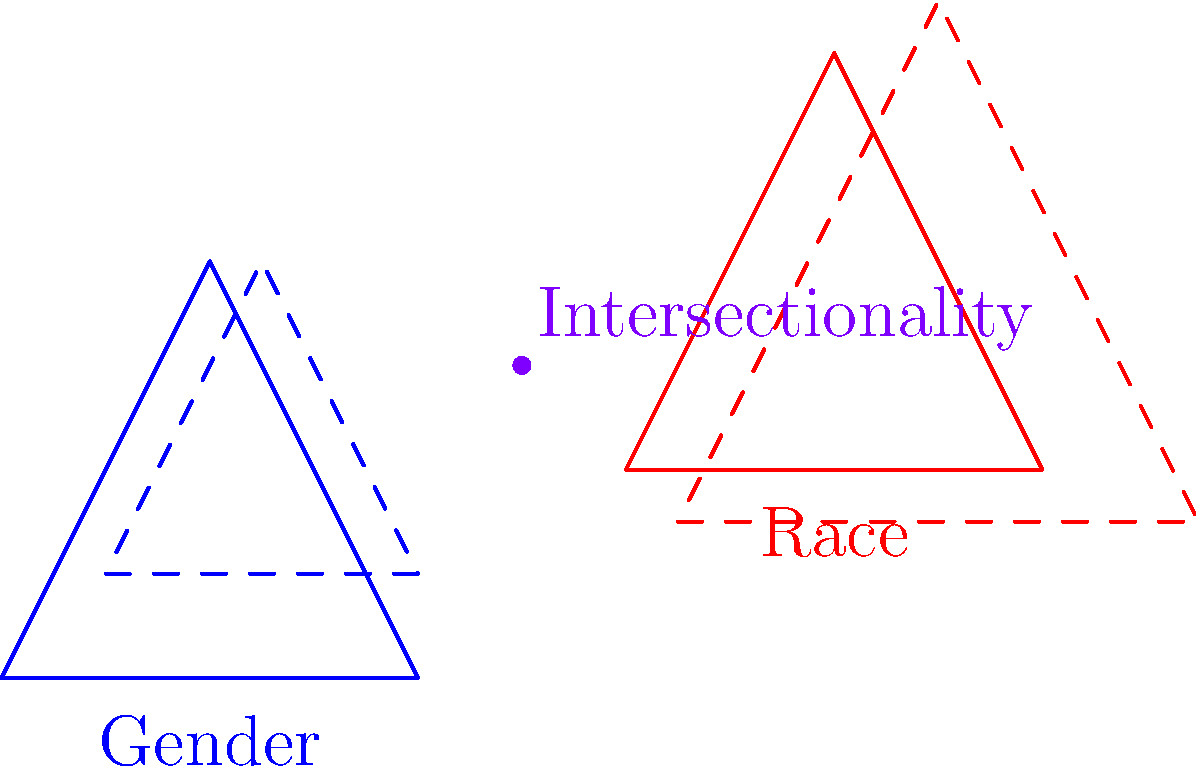In the diagram, two triangles represent different aspects of identity: gender (blue) and race (red). The intersection point symbolizes intersectionality in feminist theory. If we scale the blue triangle by a factor of 0.75 and translate it by (0.5, 0.5), and scale the red triangle by a factor of 1.25 and translate it by (-0.5, -0.5), how does this transformation affect the intersectionality point? Explain the significance of this transformation in terms of Regina Kunzel's work on intersectional analysis in gender and sexuality studies. To understand the transformation's effect on the intersectionality point, let's follow these steps:

1. Original intersectionality point: (2.5, 1.5)

2. Blue triangle (gender) transformation:
   a. Scale by 0.75: $(2.5 * 0.75, 1.5 * 0.75) = (1.875, 1.125)$
   b. Translate by (0.5, 0.5): $(1.875 + 0.5, 1.125 + 0.5) = (2.375, 1.625)$

3. Red triangle (race) transformation:
   a. Scale by 1.25: $(2.5 * 1.25, 1.5 * 1.25) = (3.125, 1.875)$
   b. Translate by (-0.5, -0.5): $(3.125 - 0.5, 1.875 - 0.5) = (2.625, 1.375)$

4. The new intersectionality point would be between (2.375, 1.625) and (2.625, 1.375)

This transformation reflects Kunzel's work on intersectional analysis by demonstrating:

a. The dynamic nature of intersectionality: The shifting point shows that intersections of identity are not fixed but can change based on context and perspective.

b. Relative importance of factors: The scaling represents how certain aspects of identity may become more or less prominent in different situations.

c. Contextual shifts: The translation symbolizes how social, cultural, or historical contexts can shift the relationship between different identity factors.

d. Complexity of identity: The transformation illustrates that understanding intersectionality requires considering multiple, simultaneous changes in how identity categories interact.

e. Non-additive nature: The new intersection point is not a simple combination of the individual transformations, reflecting Kunzel's emphasis on the complex, non-additive nature of intersectional identities.
Answer: The transformation shifts the intersectionality point, illustrating the dynamic, context-dependent nature of intersectional identities in Kunzel's work. 